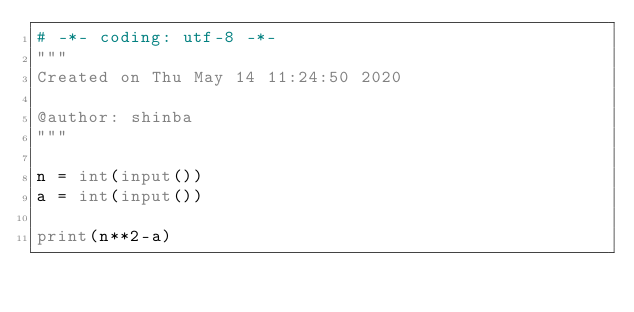Convert code to text. <code><loc_0><loc_0><loc_500><loc_500><_Python_># -*- coding: utf-8 -*-
"""
Created on Thu May 14 11:24:50 2020

@author: shinba
"""

n = int(input())
a = int(input())

print(n**2-a)</code> 